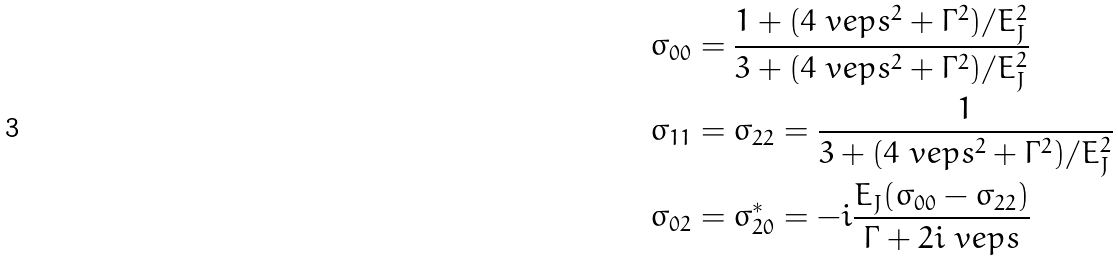Convert formula to latex. <formula><loc_0><loc_0><loc_500><loc_500>\sigma _ { 0 0 } & = \frac { 1 + ( 4 \ v e p s ^ { 2 } + \Gamma ^ { 2 } ) / E _ { J } ^ { 2 } } { 3 + ( 4 \ v e p s ^ { 2 } + \Gamma ^ { 2 } ) / E _ { J } ^ { 2 } } \\ \sigma _ { 1 1 } & = \sigma _ { 2 2 } = \frac { 1 } { 3 + ( 4 \ v e p s ^ { 2 } + \Gamma ^ { 2 } ) / E _ { J } ^ { 2 } } \\ \sigma _ { 0 2 } & = \sigma _ { 2 0 } ^ { * } = - i \frac { E _ { J } ( \sigma _ { 0 0 } - \sigma _ { 2 2 } ) } { \Gamma + 2 i \ v e p s }</formula> 